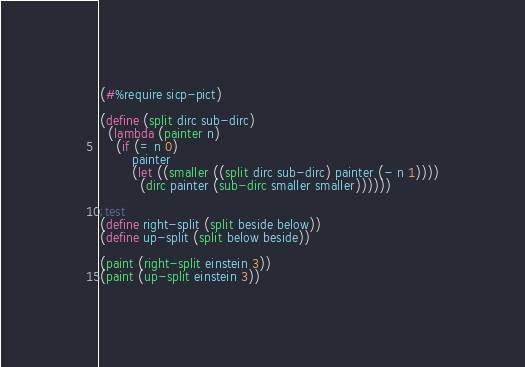<code> <loc_0><loc_0><loc_500><loc_500><_Scheme_>(#%require sicp-pict)

(define (split dirc sub-dirc)
  (lambda (painter n)
    (if (= n 0)
        painter
        (let ((smaller ((split dirc sub-dirc) painter (- n 1))))
          (dirc painter (sub-dirc smaller smaller))))))

;test
(define right-split (split beside below))
(define up-split (split below beside))

(paint (right-split einstein 3))
(paint (up-split einstein 3))</code> 